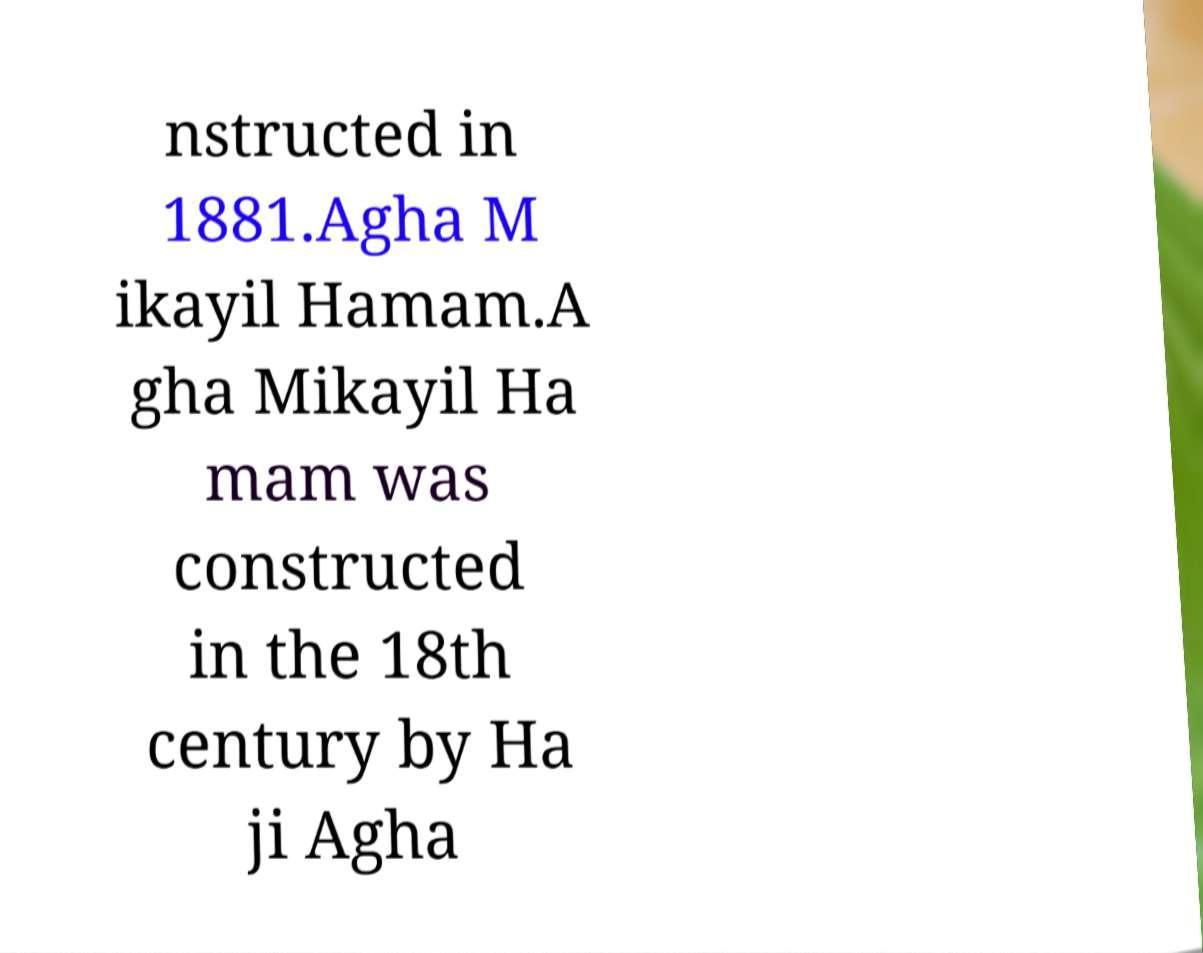Can you read and provide the text displayed in the image?This photo seems to have some interesting text. Can you extract and type it out for me? nstructed in 1881.Agha M ikayil Hamam.A gha Mikayil Ha mam was constructed in the 18th century by Ha ji Agha 